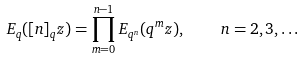Convert formula to latex. <formula><loc_0><loc_0><loc_500><loc_500>E _ { q } ( [ n ] _ { q } z ) = \prod _ { m = 0 } ^ { n - 1 } E _ { q ^ { n } } ( q ^ { m } z ) , \quad n = 2 , 3 , \dots</formula> 